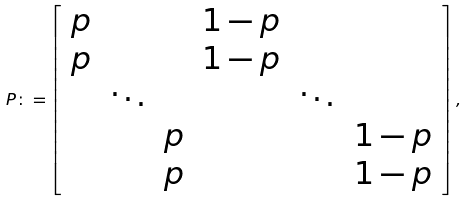Convert formula to latex. <formula><loc_0><loc_0><loc_500><loc_500>P \colon = \left [ \begin{array} { c c c c c c } p & & & 1 - p & & \\ p & & & 1 - p & & \\ & \ddots & & & \ddots & \\ & & p & & & 1 - p \\ & & p & & & 1 - p \end{array} \right ] ,</formula> 